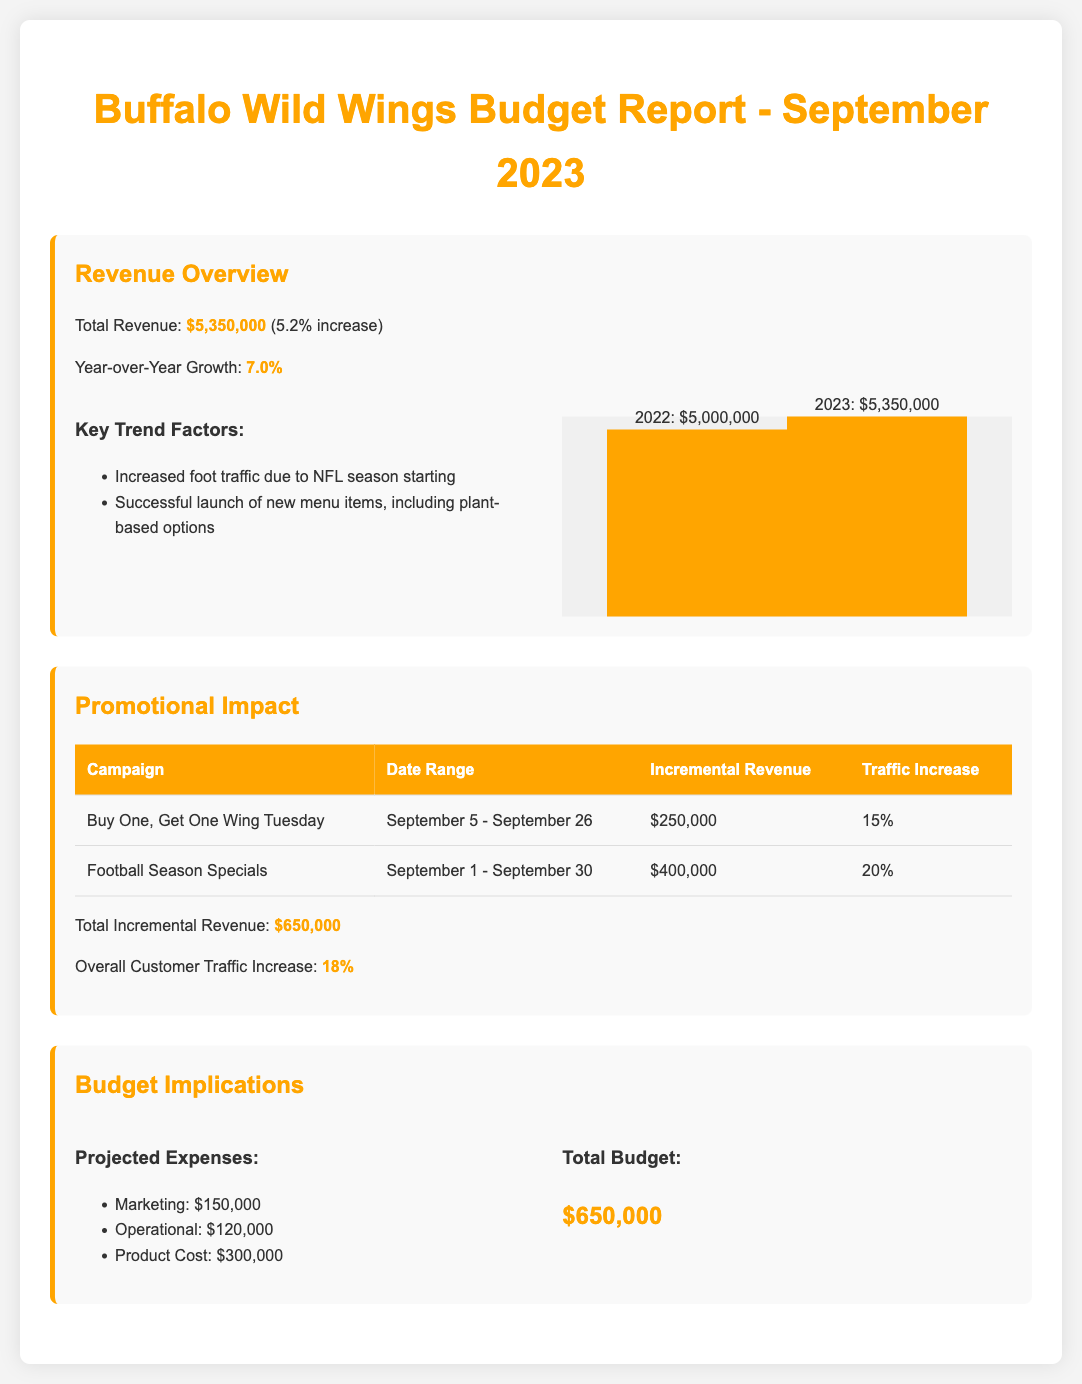What is the total revenue for September 2023? The total revenue is clearly stated in the document in the revenue overview section.
Answer: $5,350,000 What was the year-over-year growth in revenue? The year-over-year growth is presented in the revenue overview section.
Answer: 7.0% What was the incremental revenue from the Football Season Specials campaign? The incremental revenue from each promotional campaign is listed in the promotional impact section.
Answer: $400,000 How much did the Buy One, Get One Wing Tuesday campaign contribute to incremental revenue? The document provides specific revenue contributions for each promotional campaign.
Answer: $250,000 What was the overall customer traffic increase for September 2023? The overall customer traffic increase is summarized in the promotional impact section.
Answer: 18% What are the projected marketing expenses? The projected expenses are detailed in the budget implications section under projected expenses.
Answer: $150,000 What is the total budget allocated for September 2023? The total budget is highlighted in the budget implications section.
Answer: $650,000 What factor contributed to increased foot traffic? The document lists key trend factors that affected revenue, including increased foot traffic due to the NFL season.
Answer: NFL season What was the traffic increase due to the Football Season Specials? The document mentions the traffic increase associated with the Football Season Specials campaign.
Answer: 20% 